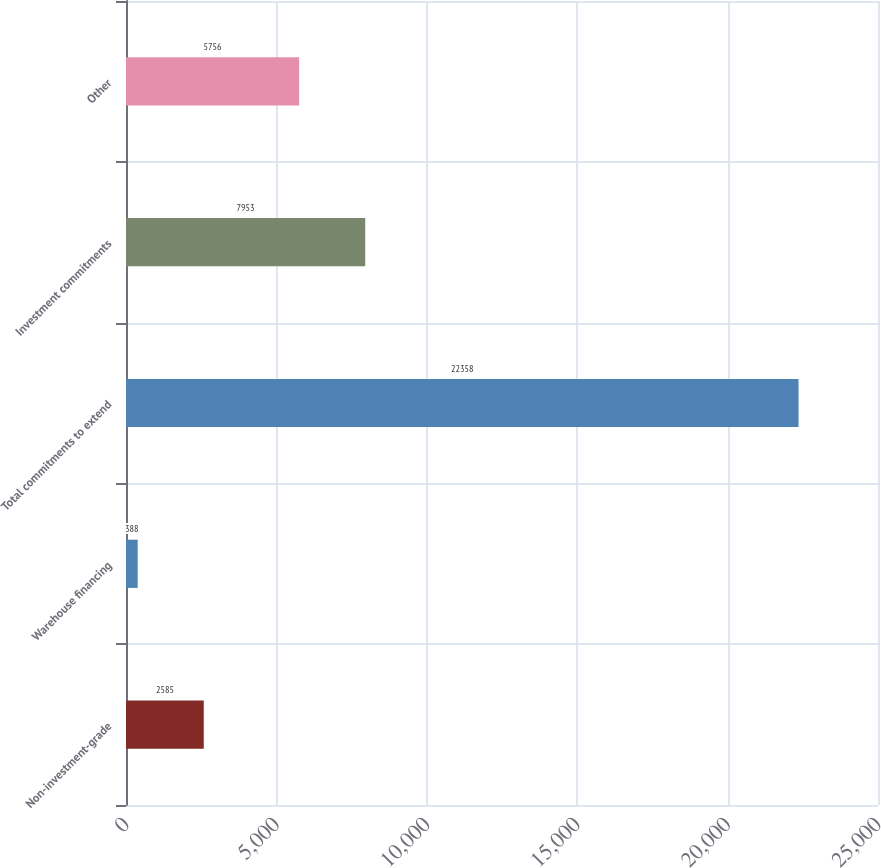Convert chart. <chart><loc_0><loc_0><loc_500><loc_500><bar_chart><fcel>Non-investment-grade<fcel>Warehouse financing<fcel>Total commitments to extend<fcel>Investment commitments<fcel>Other<nl><fcel>2585<fcel>388<fcel>22358<fcel>7953<fcel>5756<nl></chart> 